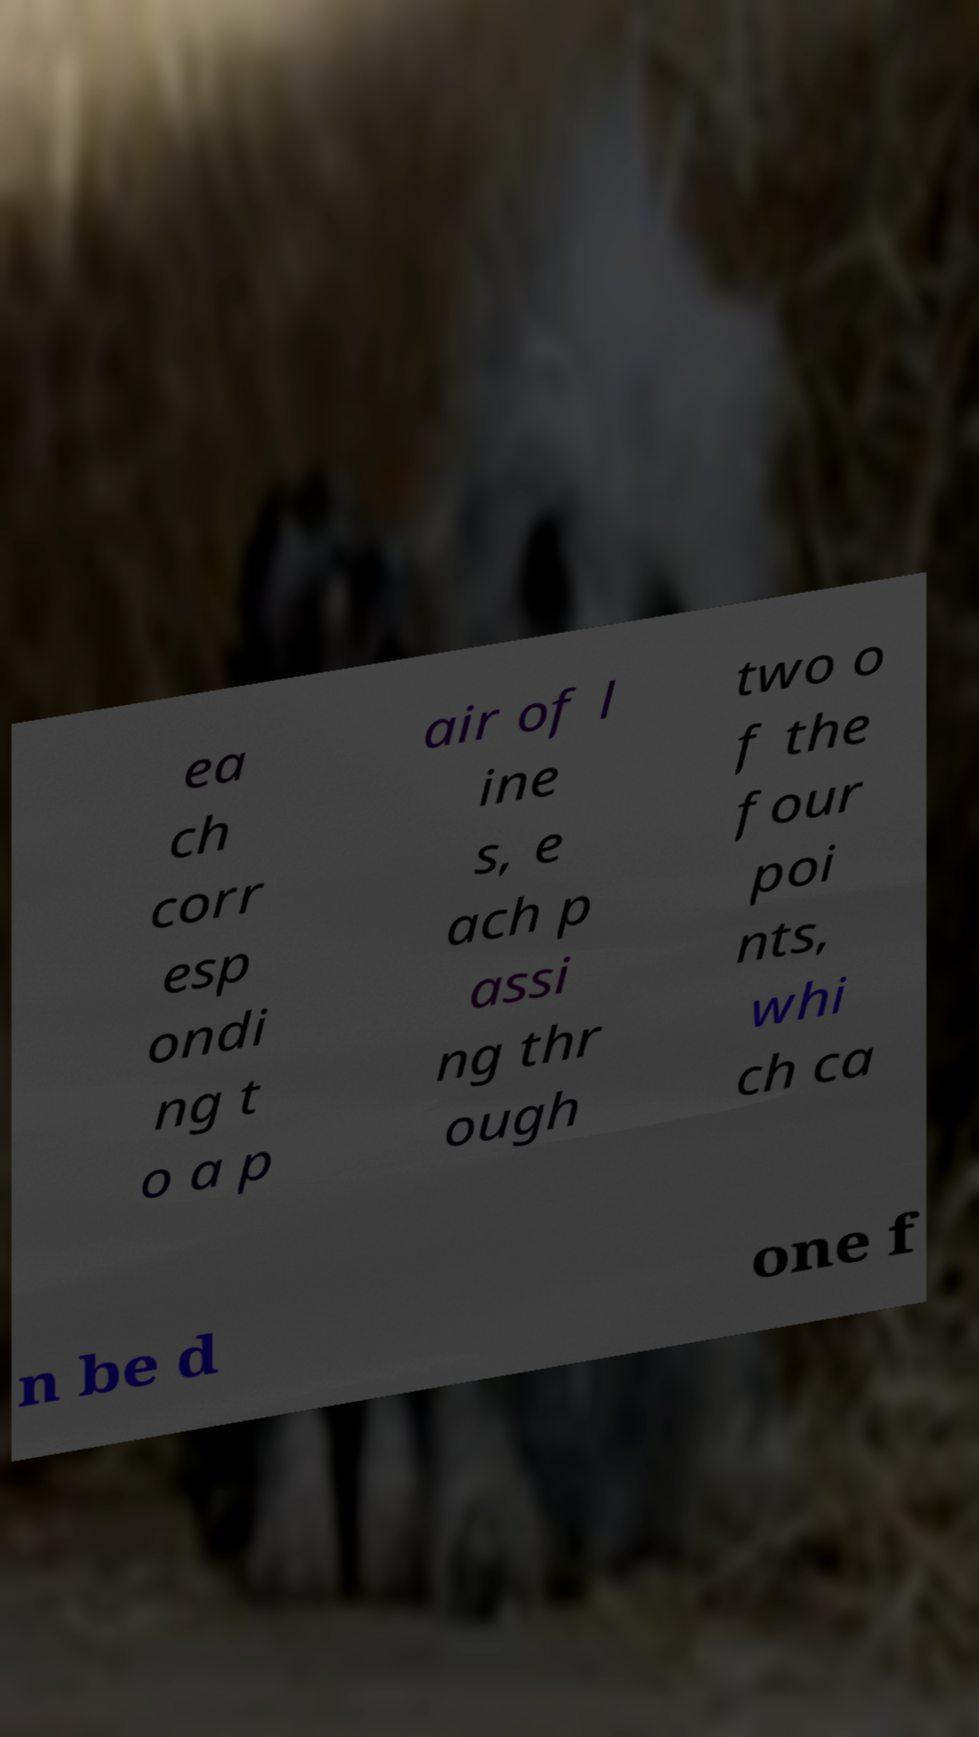Can you accurately transcribe the text from the provided image for me? ea ch corr esp ondi ng t o a p air of l ine s, e ach p assi ng thr ough two o f the four poi nts, whi ch ca n be d one f 